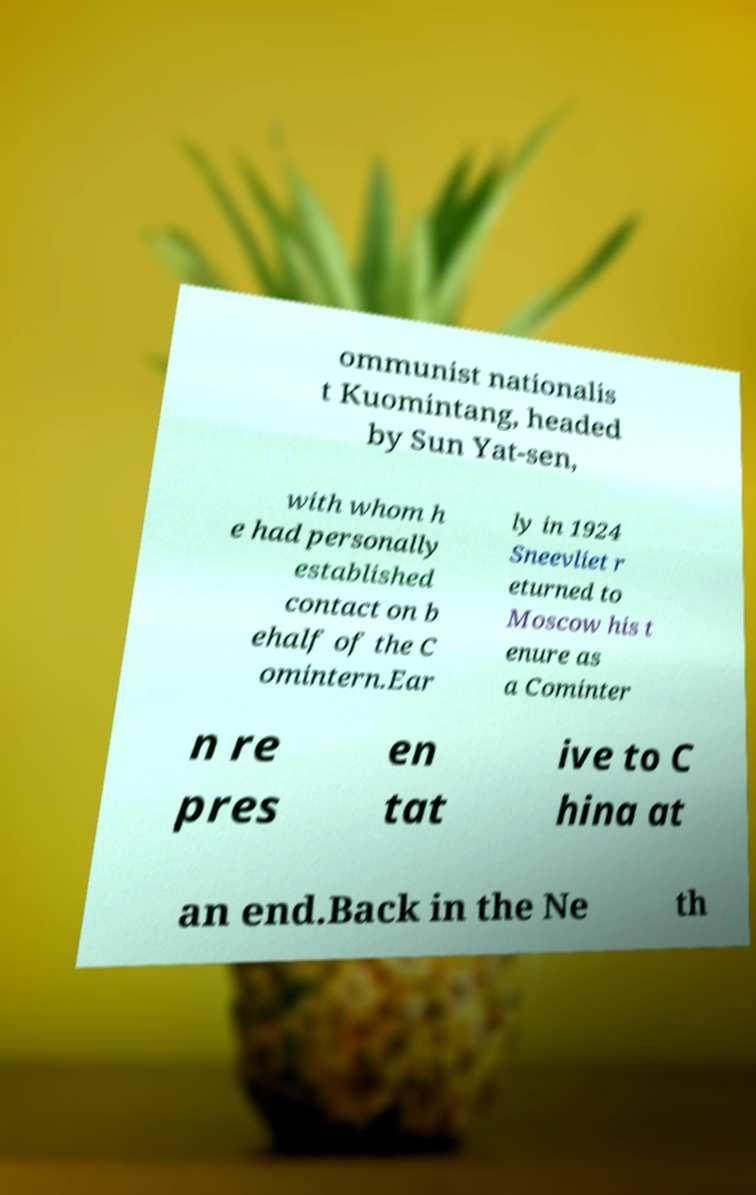Could you assist in decoding the text presented in this image and type it out clearly? ommunist nationalis t Kuomintang, headed by Sun Yat-sen, with whom h e had personally established contact on b ehalf of the C omintern.Ear ly in 1924 Sneevliet r eturned to Moscow his t enure as a Cominter n re pres en tat ive to C hina at an end.Back in the Ne th 